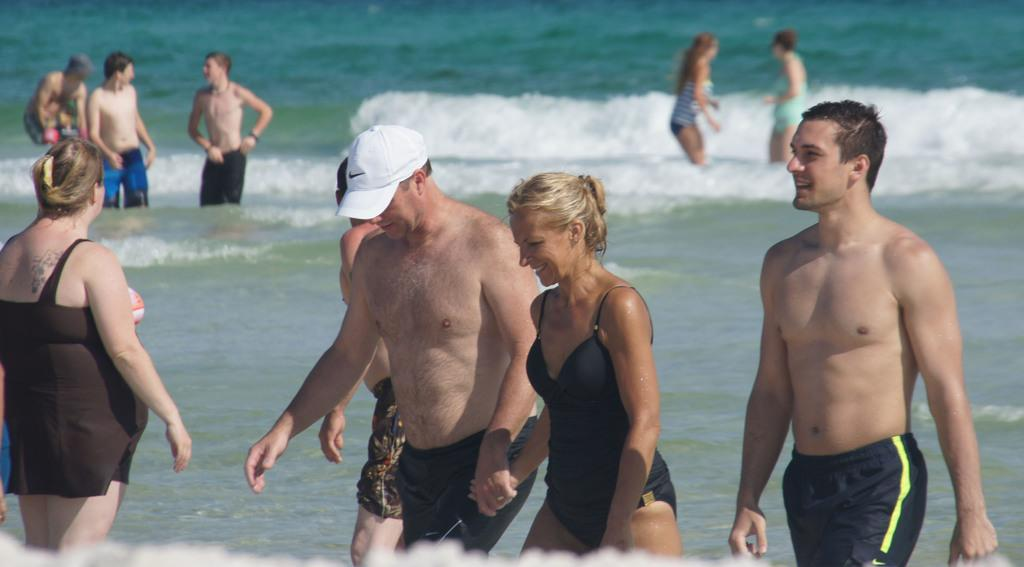What are the people in the image doing? The people in the image are standing in the water. Can you describe the actions of the three persons in the front? The three persons in the front are walking. What can be seen on the head of the man in the middle? The man in the middle is wearing a cap. What is visible at the bottom of the image? Water is visible at the bottom of the image. What type of plant is causing a reaction in the water in the image? There is no plant present in the image, nor is there any indication of a reaction occurring in the water. 